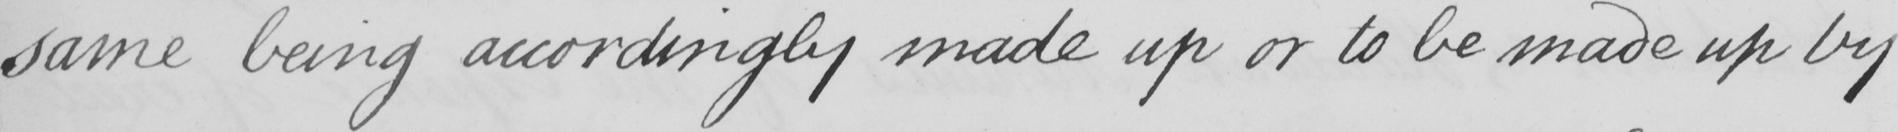What is written in this line of handwriting? same being accordingly made up or to be made up by 